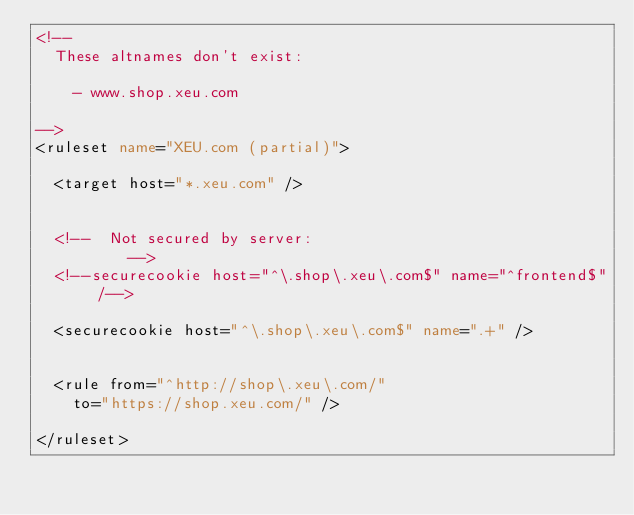Convert code to text. <code><loc_0><loc_0><loc_500><loc_500><_XML_><!--
	These altnames don't exist:

		- www.shop.xeu.com

-->
<ruleset name="XEU.com (partial)">

	<target host="*.xeu.com" />


	<!--	Not secured by server:
					-->
	<!--securecookie host="^\.shop\.xeu\.com$" name="^frontend$" /-->

	<securecookie host="^\.shop\.xeu\.com$" name=".+" />


	<rule from="^http://shop\.xeu\.com/"
		to="https://shop.xeu.com/" />

</ruleset>
</code> 